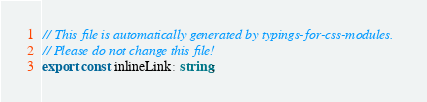<code> <loc_0><loc_0><loc_500><loc_500><_TypeScript_>// This file is automatically generated by typings-for-css-modules.
// Please do not change this file!
export const inlineLink: string;
</code> 